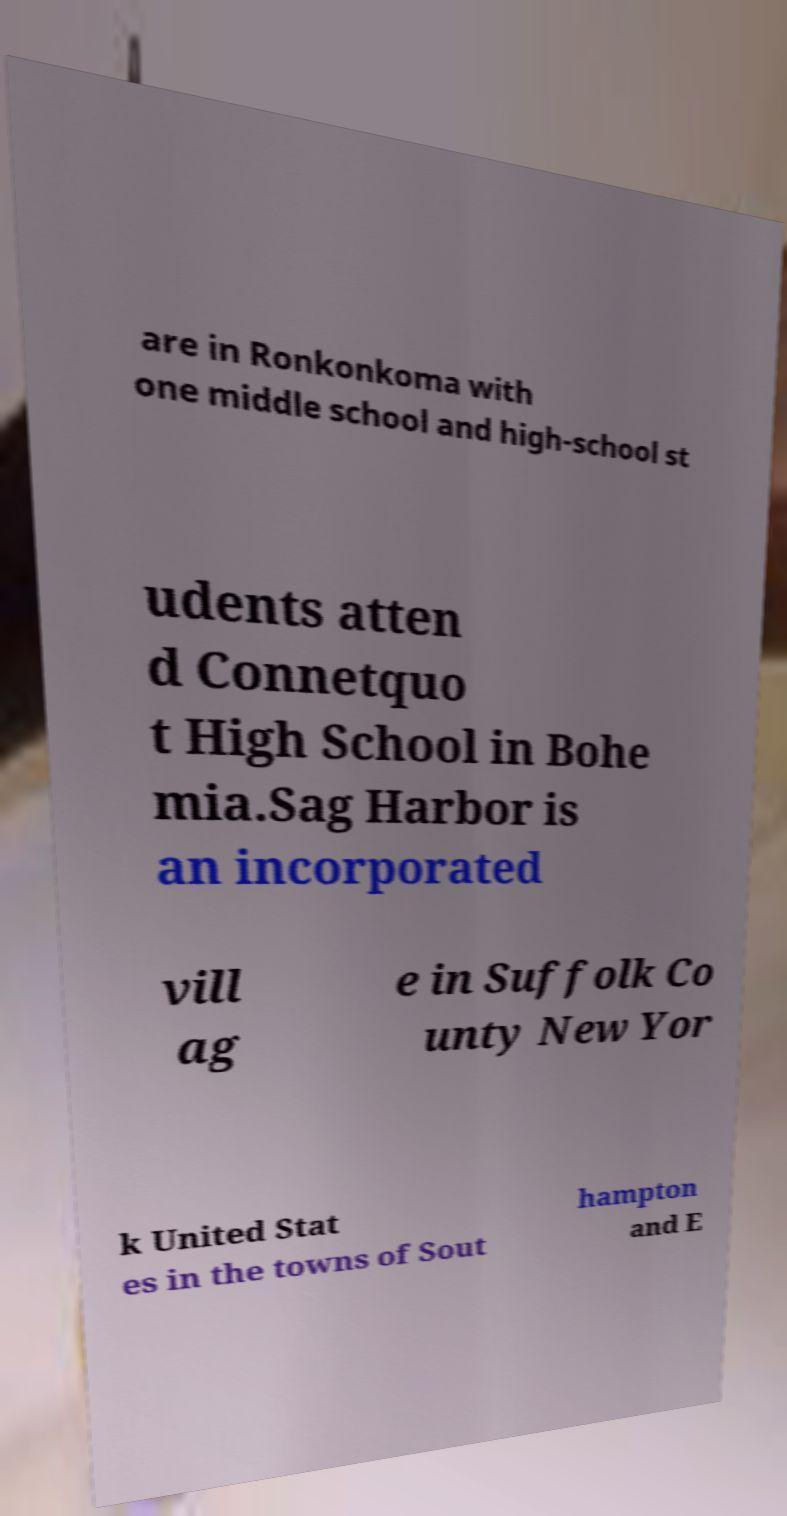Please identify and transcribe the text found in this image. are in Ronkonkoma with one middle school and high-school st udents atten d Connetquo t High School in Bohe mia.Sag Harbor is an incorporated vill ag e in Suffolk Co unty New Yor k United Stat es in the towns of Sout hampton and E 